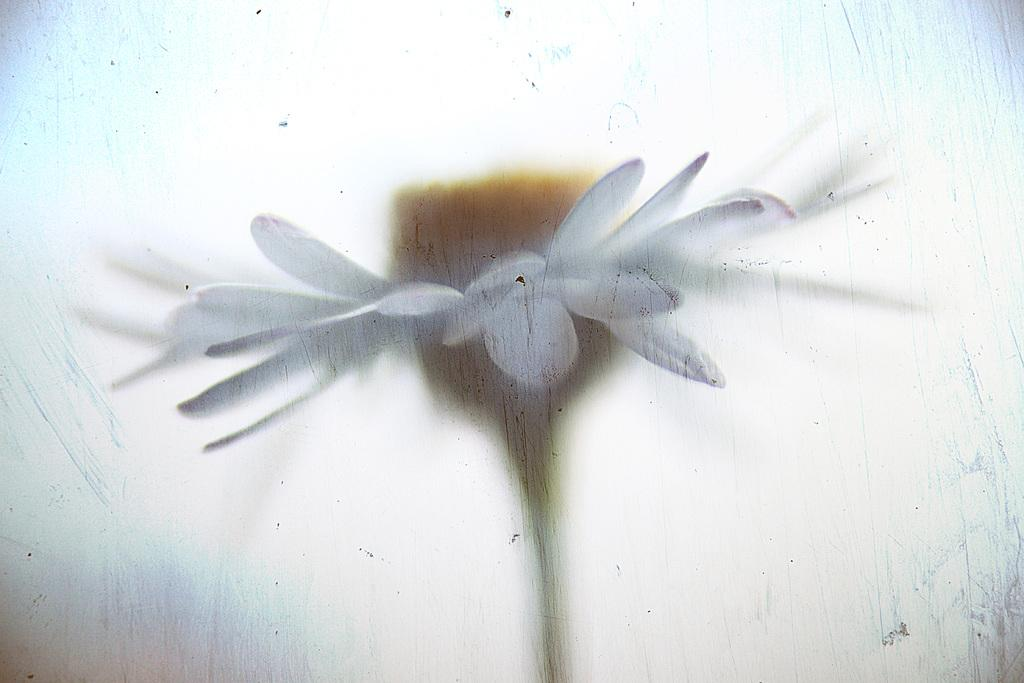What type of flower is in the image? There is a white color flower in the image. How is the flower's appearance in the image? The flower is slightly blurred. What color is the background of the image? The background of the image is in white color. What type of spoon is visible in the image? There is no spoon present in the image. Can you see the arm of the person holding the camera in the image? There is no person or arm visible in the image; it only features a white color flower with a white background. 